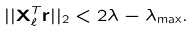<formula> <loc_0><loc_0><loc_500><loc_500>| | \mathbf X _ { \ell } ^ { T } \mathbf r | | _ { 2 } < 2 \lambda - \lambda _ { \max } .</formula> 